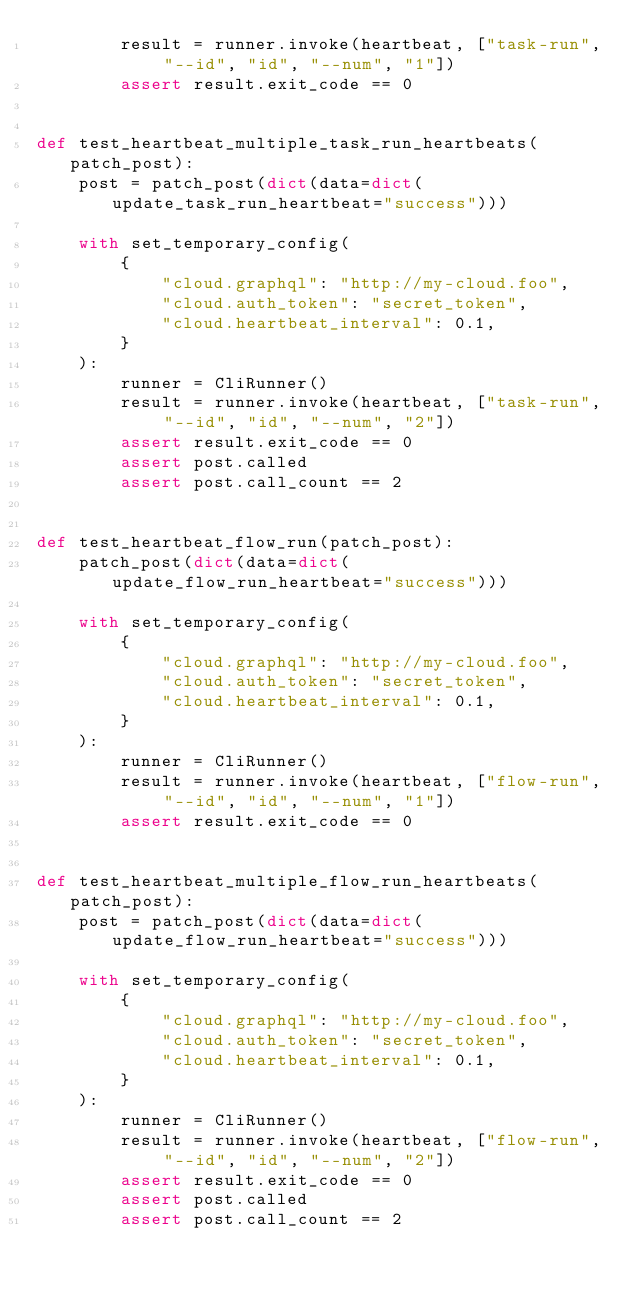Convert code to text. <code><loc_0><loc_0><loc_500><loc_500><_Python_>        result = runner.invoke(heartbeat, ["task-run", "--id", "id", "--num", "1"])
        assert result.exit_code == 0


def test_heartbeat_multiple_task_run_heartbeats(patch_post):
    post = patch_post(dict(data=dict(update_task_run_heartbeat="success")))

    with set_temporary_config(
        {
            "cloud.graphql": "http://my-cloud.foo",
            "cloud.auth_token": "secret_token",
            "cloud.heartbeat_interval": 0.1,
        }
    ):
        runner = CliRunner()
        result = runner.invoke(heartbeat, ["task-run", "--id", "id", "--num", "2"])
        assert result.exit_code == 0
        assert post.called
        assert post.call_count == 2


def test_heartbeat_flow_run(patch_post):
    patch_post(dict(data=dict(update_flow_run_heartbeat="success")))

    with set_temporary_config(
        {
            "cloud.graphql": "http://my-cloud.foo",
            "cloud.auth_token": "secret_token",
            "cloud.heartbeat_interval": 0.1,
        }
    ):
        runner = CliRunner()
        result = runner.invoke(heartbeat, ["flow-run", "--id", "id", "--num", "1"])
        assert result.exit_code == 0


def test_heartbeat_multiple_flow_run_heartbeats(patch_post):
    post = patch_post(dict(data=dict(update_flow_run_heartbeat="success")))

    with set_temporary_config(
        {
            "cloud.graphql": "http://my-cloud.foo",
            "cloud.auth_token": "secret_token",
            "cloud.heartbeat_interval": 0.1,
        }
    ):
        runner = CliRunner()
        result = runner.invoke(heartbeat, ["flow-run", "--id", "id", "--num", "2"])
        assert result.exit_code == 0
        assert post.called
        assert post.call_count == 2
</code> 